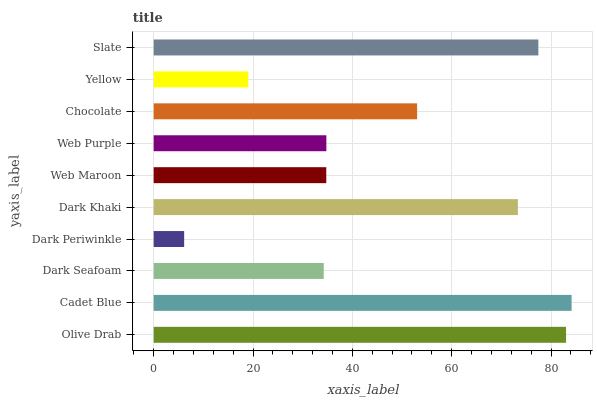Is Dark Periwinkle the minimum?
Answer yes or no. Yes. Is Cadet Blue the maximum?
Answer yes or no. Yes. Is Dark Seafoam the minimum?
Answer yes or no. No. Is Dark Seafoam the maximum?
Answer yes or no. No. Is Cadet Blue greater than Dark Seafoam?
Answer yes or no. Yes. Is Dark Seafoam less than Cadet Blue?
Answer yes or no. Yes. Is Dark Seafoam greater than Cadet Blue?
Answer yes or no. No. Is Cadet Blue less than Dark Seafoam?
Answer yes or no. No. Is Chocolate the high median?
Answer yes or no. Yes. Is Web Purple the low median?
Answer yes or no. Yes. Is Slate the high median?
Answer yes or no. No. Is Chocolate the low median?
Answer yes or no. No. 